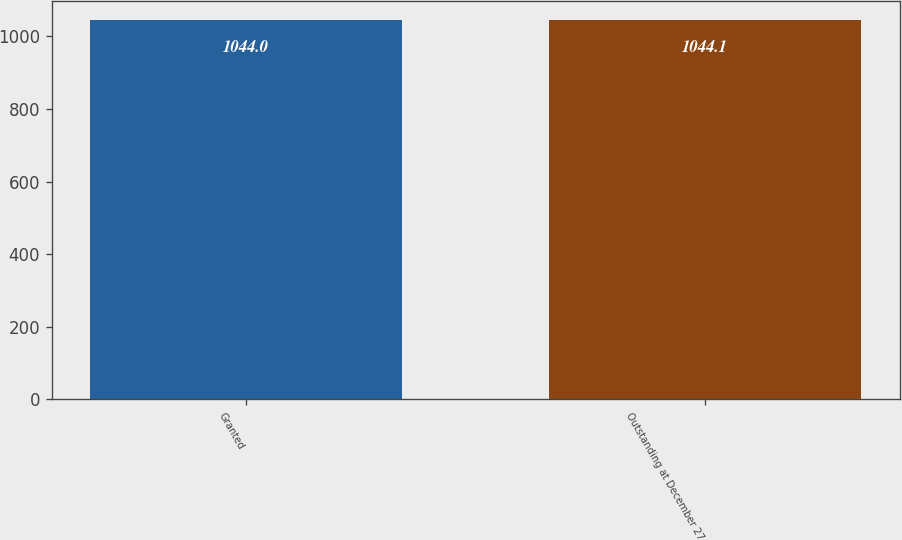Convert chart to OTSL. <chart><loc_0><loc_0><loc_500><loc_500><bar_chart><fcel>Granted<fcel>Outstanding at December 27<nl><fcel>1044<fcel>1044.1<nl></chart> 